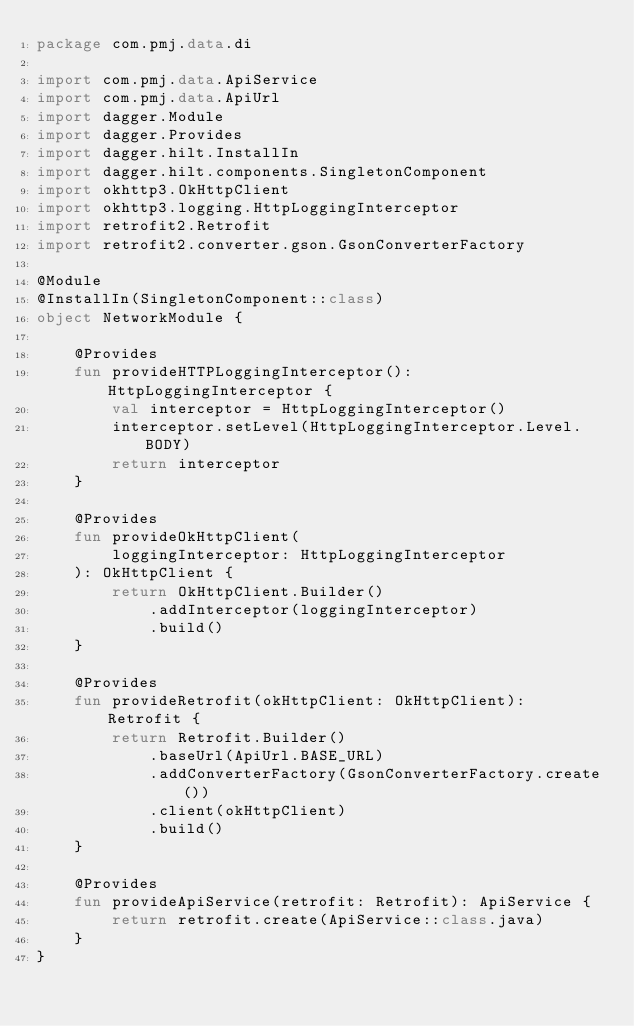<code> <loc_0><loc_0><loc_500><loc_500><_Kotlin_>package com.pmj.data.di

import com.pmj.data.ApiService
import com.pmj.data.ApiUrl
import dagger.Module
import dagger.Provides
import dagger.hilt.InstallIn
import dagger.hilt.components.SingletonComponent
import okhttp3.OkHttpClient
import okhttp3.logging.HttpLoggingInterceptor
import retrofit2.Retrofit
import retrofit2.converter.gson.GsonConverterFactory

@Module
@InstallIn(SingletonComponent::class)
object NetworkModule {

    @Provides
    fun provideHTTPLoggingInterceptor(): HttpLoggingInterceptor {
        val interceptor = HttpLoggingInterceptor()
        interceptor.setLevel(HttpLoggingInterceptor.Level.BODY)
        return interceptor
    }

    @Provides
    fun provideOkHttpClient(
        loggingInterceptor: HttpLoggingInterceptor
    ): OkHttpClient {
        return OkHttpClient.Builder()
            .addInterceptor(loggingInterceptor)
            .build()
    }

    @Provides
    fun provideRetrofit(okHttpClient: OkHttpClient): Retrofit {
        return Retrofit.Builder()
            .baseUrl(ApiUrl.BASE_URL)
            .addConverterFactory(GsonConverterFactory.create())
            .client(okHttpClient)
            .build()
    }

    @Provides
    fun provideApiService(retrofit: Retrofit): ApiService {
        return retrofit.create(ApiService::class.java)
    }
}</code> 